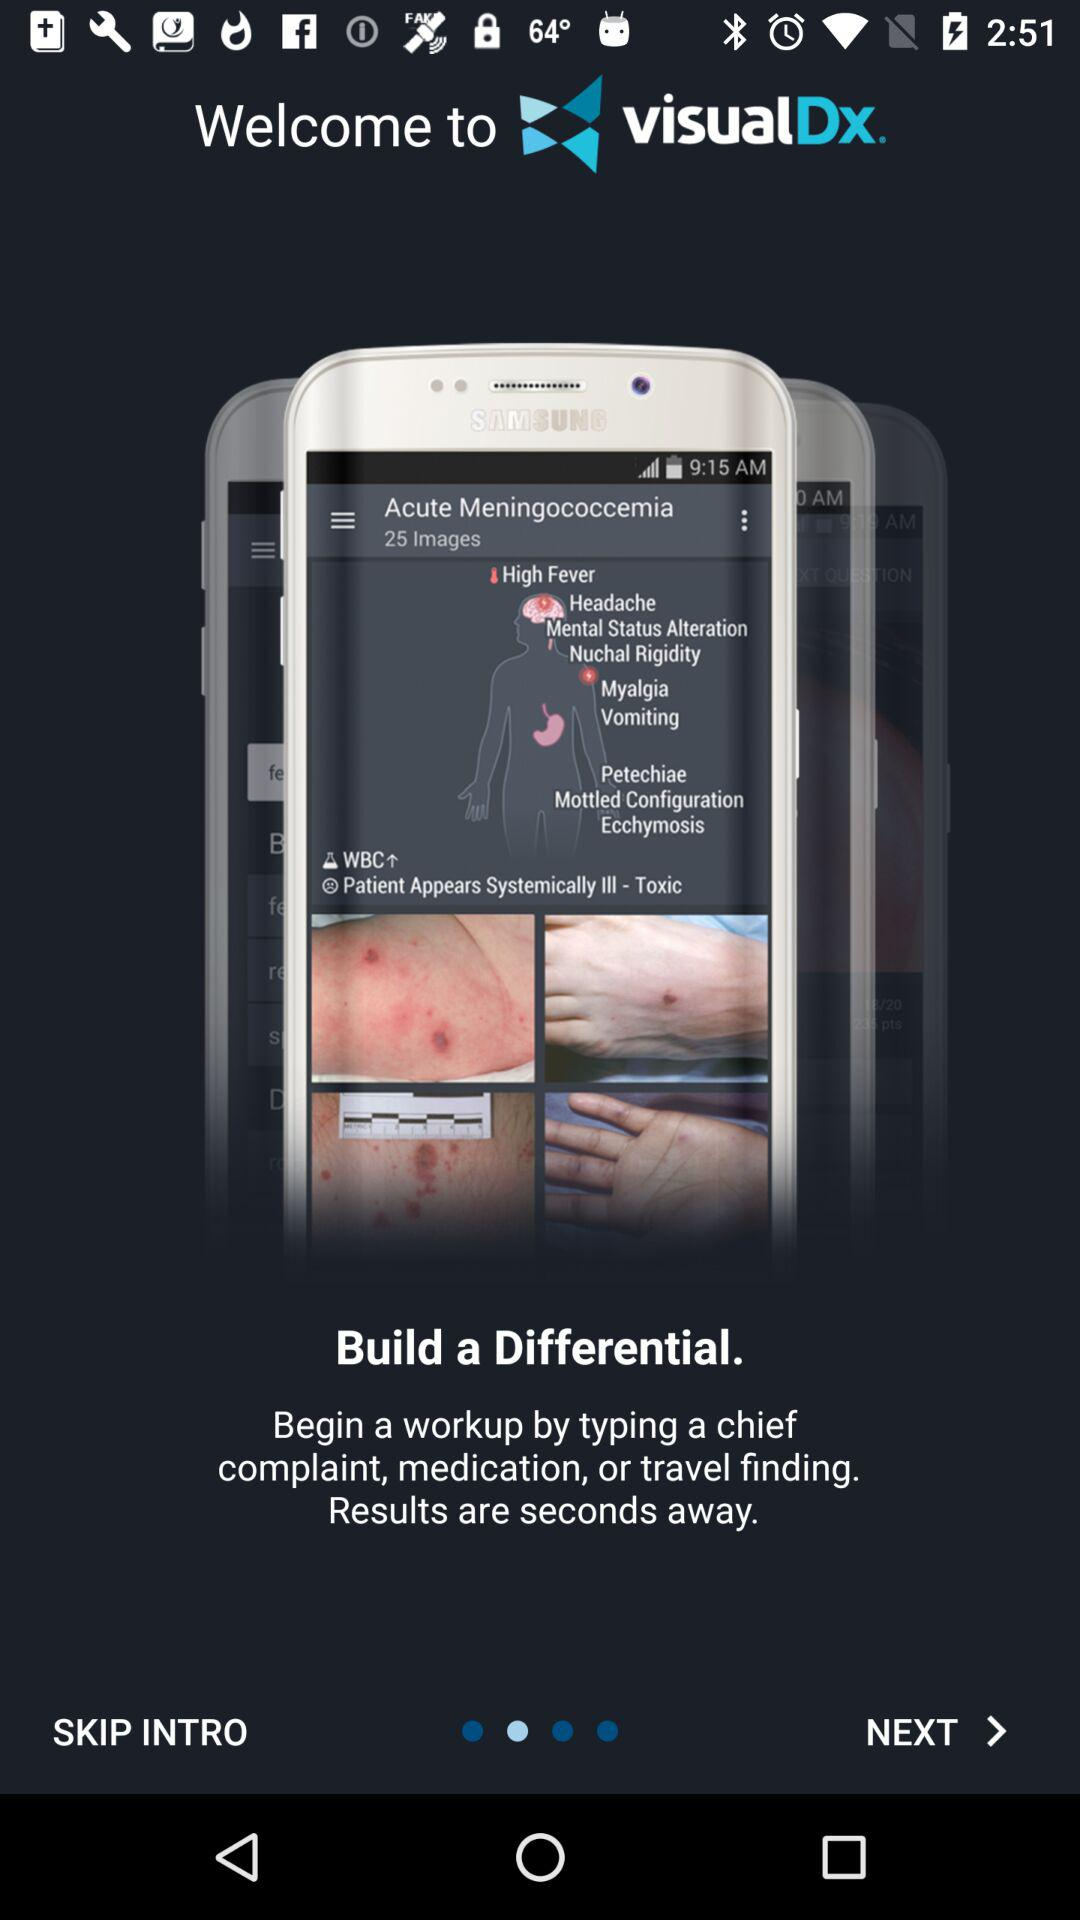What is the name of the application? The name of the application is "visualDx". 